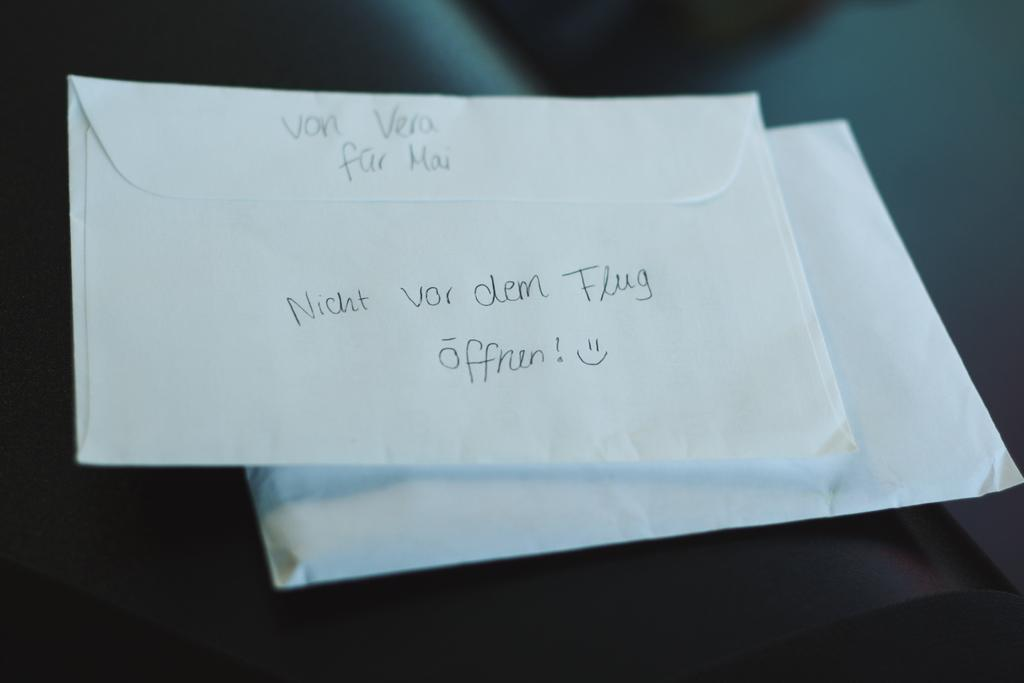<image>
Present a compact description of the photo's key features. Two envelopes with some writing in the back that appears to be in German. 